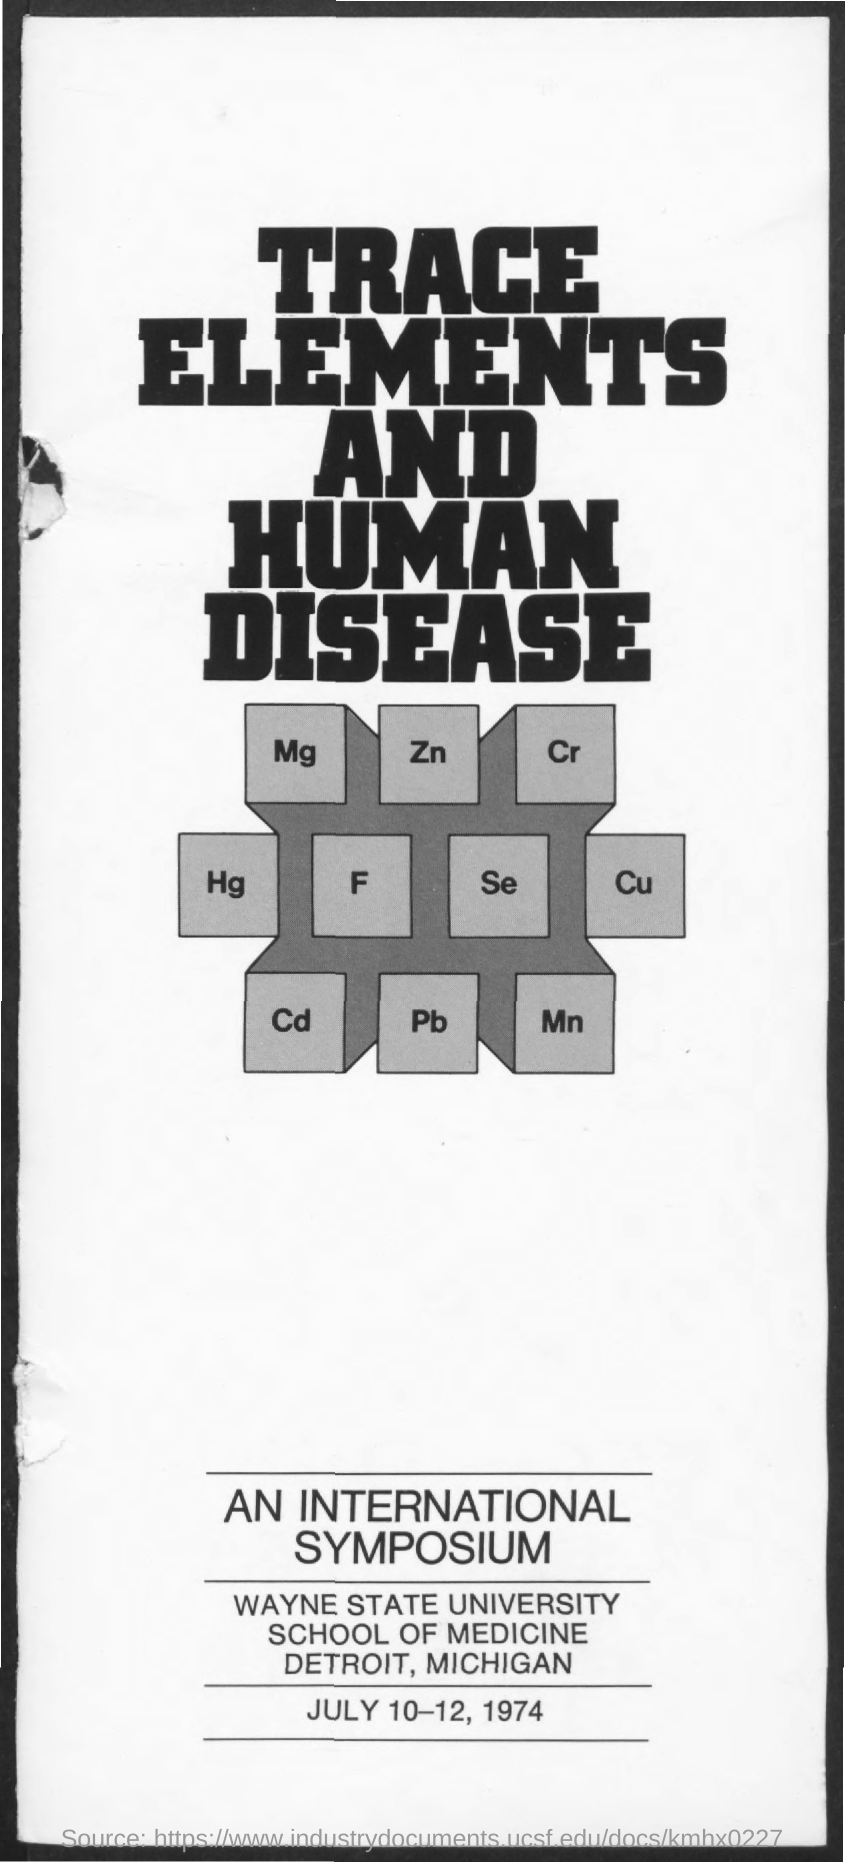Point out several critical features in this image. The name of the university is Wayne State University. The date mentioned at the bottom is July 10-12, 1974. Wayne State University is located in the city of Detroit, Michigan. The text that is prominently displayed in large, bold letters reads, 'Trace Elements and Human Disease. 